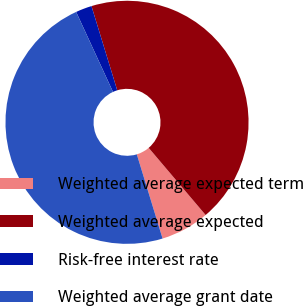Convert chart. <chart><loc_0><loc_0><loc_500><loc_500><pie_chart><fcel>Weighted average expected term<fcel>Weighted average expected<fcel>Risk-free interest rate<fcel>Weighted average grant date<nl><fcel>6.47%<fcel>43.53%<fcel>2.15%<fcel>47.85%<nl></chart> 